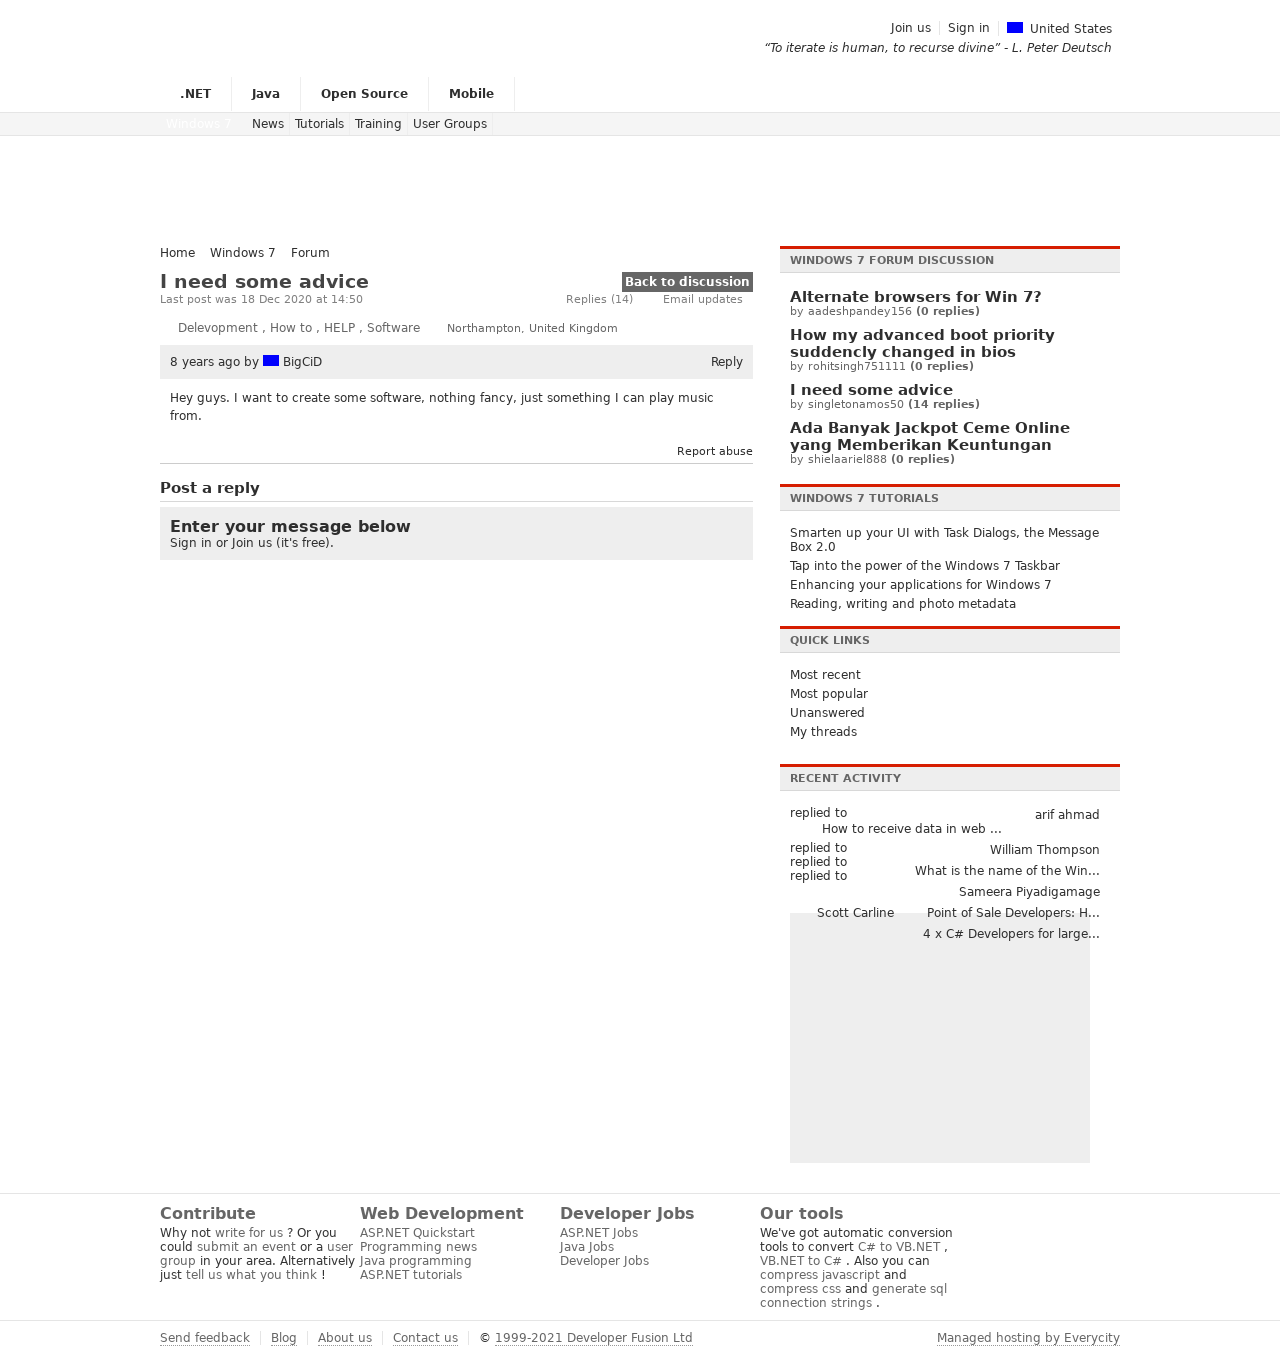What user experience principles can be observed from this forum layout? The forum layout adheres to several user experience principles. First, there's a clear hierarchy of information, with navigation menus at the top, primary content in the center, and additional resources on the sides and bottom. Readability is considered with ample white space and distinct sections for various types of content. The use of familiar icons, such as for country flags and discussion types, also taps into users' pre-existing associations to aid in navigation and understanding. Moreover, call-to-action prompts like 'Join us' and 'Sign in' in the member's area are strategically placed to encourage user participation. The color scheme and font choices aim for an uncluttered, professional atmosphere, suitable for a developer community. 